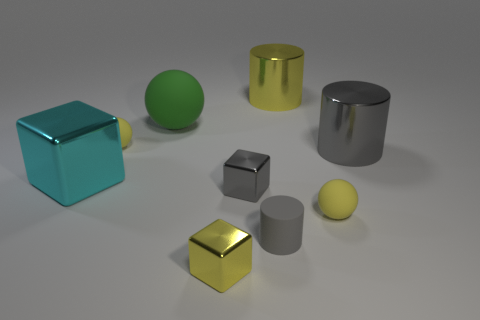Add 1 large green balls. How many objects exist? 10 Subtract all cylinders. How many objects are left? 6 Subtract 0 brown cubes. How many objects are left? 9 Subtract all tiny yellow matte things. Subtract all gray rubber cylinders. How many objects are left? 6 Add 2 big yellow things. How many big yellow things are left? 3 Add 3 big cyan matte balls. How many big cyan matte balls exist? 3 